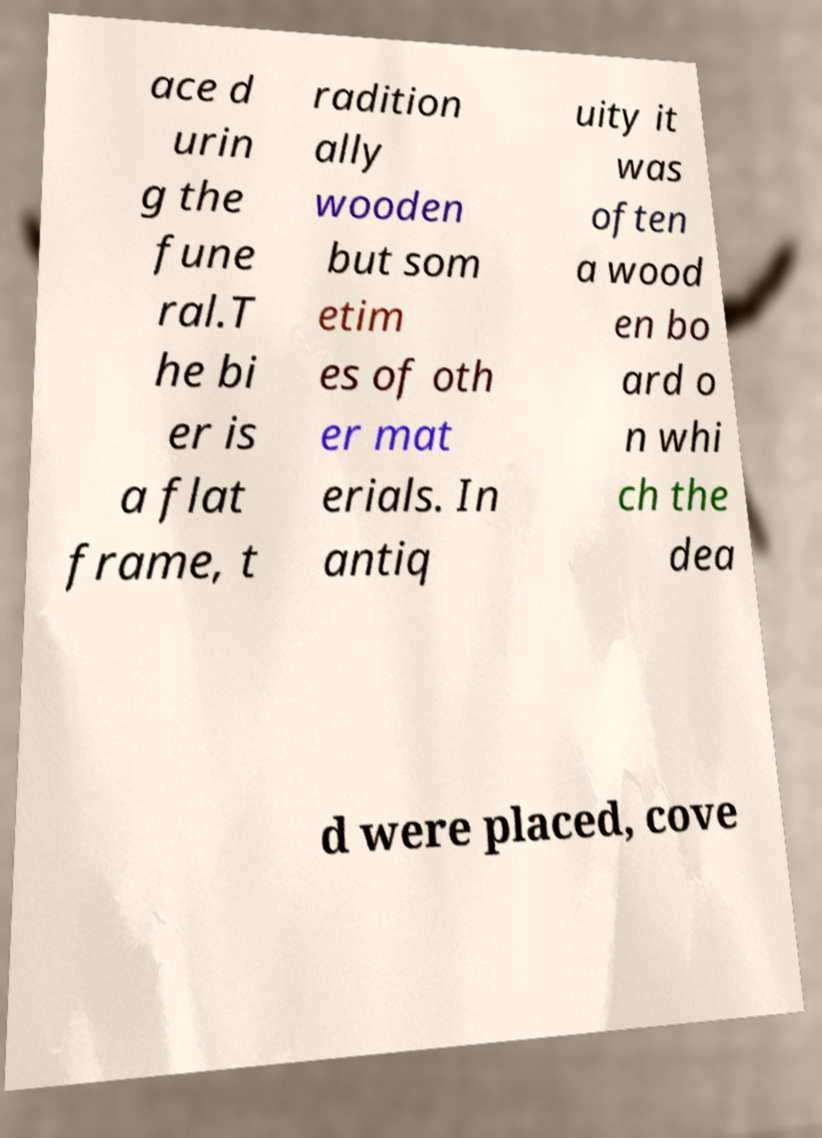Could you assist in decoding the text presented in this image and type it out clearly? ace d urin g the fune ral.T he bi er is a flat frame, t radition ally wooden but som etim es of oth er mat erials. In antiq uity it was often a wood en bo ard o n whi ch the dea d were placed, cove 